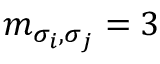Convert formula to latex. <formula><loc_0><loc_0><loc_500><loc_500>m _ { \sigma _ { i } , \sigma _ { j } } = 3</formula> 